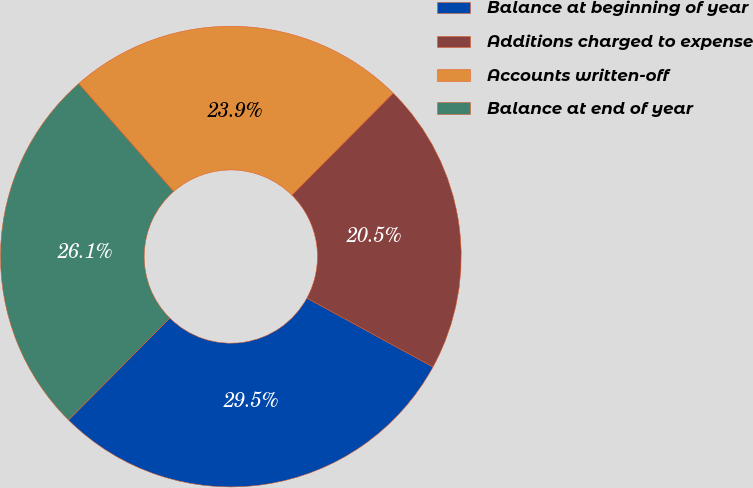Convert chart. <chart><loc_0><loc_0><loc_500><loc_500><pie_chart><fcel>Balance at beginning of year<fcel>Additions charged to expense<fcel>Accounts written-off<fcel>Balance at end of year<nl><fcel>29.49%<fcel>20.51%<fcel>23.93%<fcel>26.07%<nl></chart> 